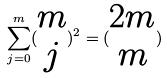Convert formula to latex. <formula><loc_0><loc_0><loc_500><loc_500>\sum _ { j = 0 } ^ { m } ( \begin{matrix} m \\ j \end{matrix} ) ^ { 2 } = ( \begin{matrix} 2 m \\ m \end{matrix} )</formula> 